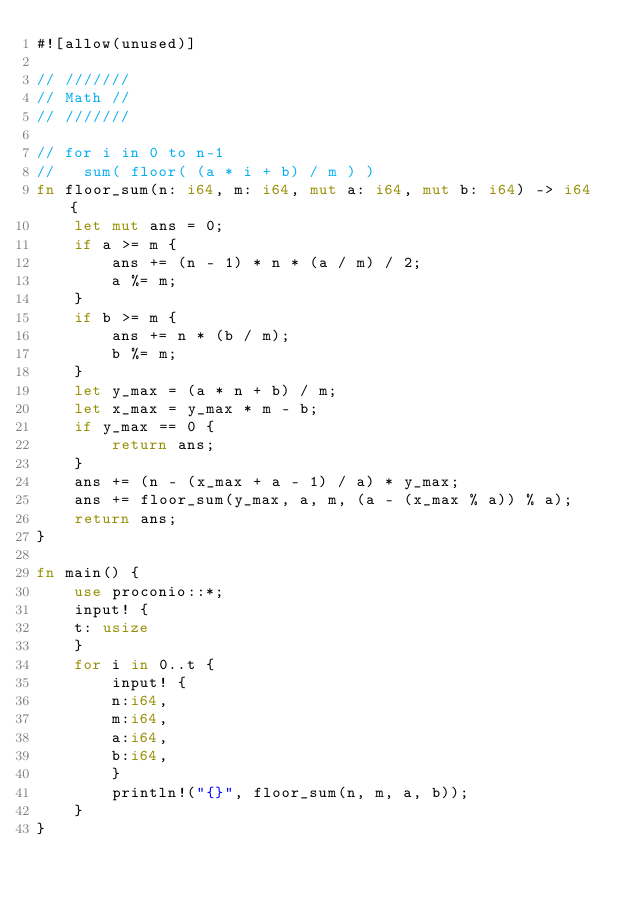<code> <loc_0><loc_0><loc_500><loc_500><_Rust_>#![allow(unused)]

// ///////
// Math //
// ///////

// for i in 0 to n-1
//   sum( floor( (a * i + b) / m ) )
fn floor_sum(n: i64, m: i64, mut a: i64, mut b: i64) -> i64 {
    let mut ans = 0;
    if a >= m {
        ans += (n - 1) * n * (a / m) / 2;
        a %= m;
    }
    if b >= m {
        ans += n * (b / m);
        b %= m;
    }
    let y_max = (a * n + b) / m;
    let x_max = y_max * m - b;
    if y_max == 0 {
        return ans;
    }
    ans += (n - (x_max + a - 1) / a) * y_max;
    ans += floor_sum(y_max, a, m, (a - (x_max % a)) % a);
    return ans;
}

fn main() {
    use proconio::*;
    input! {
    t: usize
    }
    for i in 0..t {
        input! {
        n:i64,
        m:i64,
        a:i64,
        b:i64,
        }
        println!("{}", floor_sum(n, m, a, b));
    }
}
</code> 